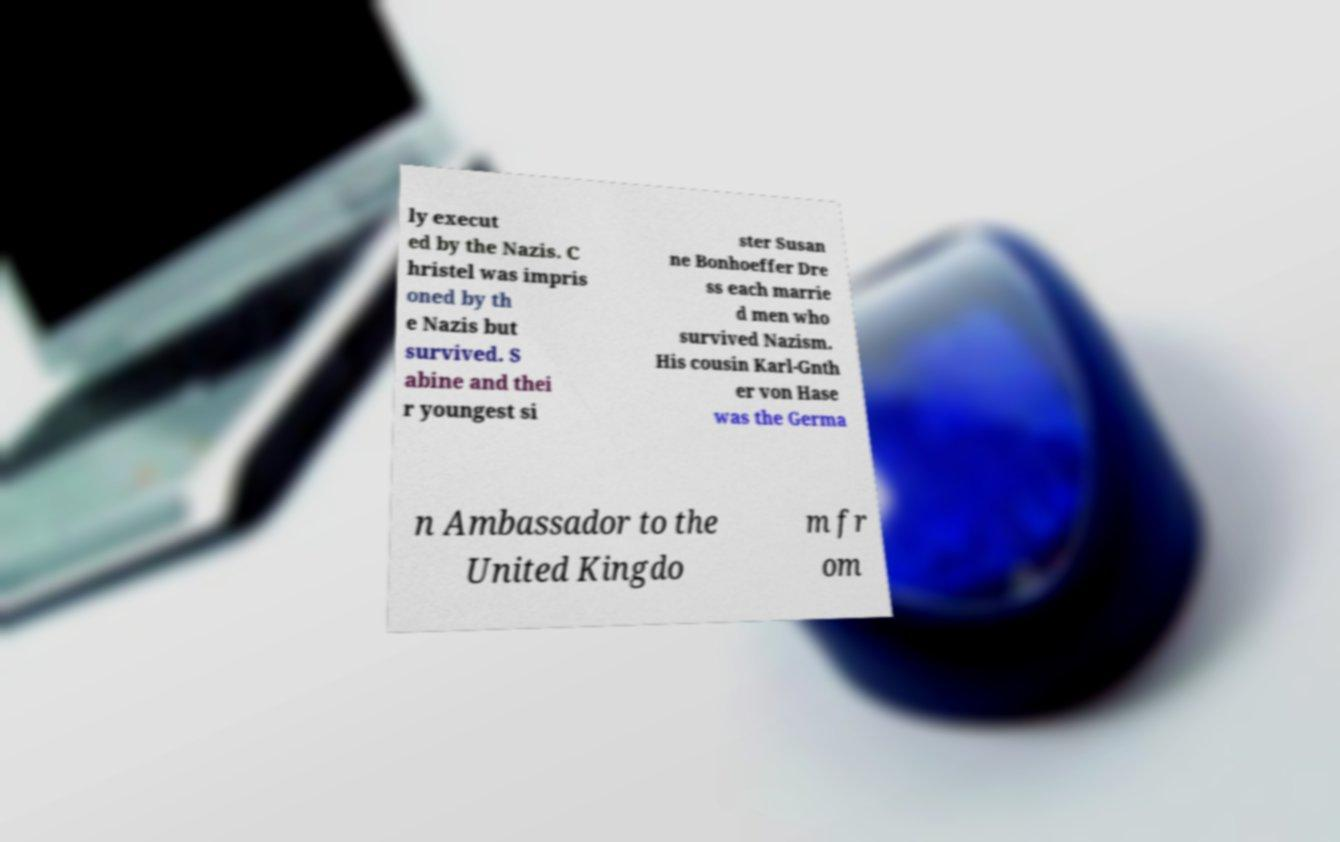Could you extract and type out the text from this image? ly execut ed by the Nazis. C hristel was impris oned by th e Nazis but survived. S abine and thei r youngest si ster Susan ne Bonhoeffer Dre ss each marrie d men who survived Nazism. His cousin Karl-Gnth er von Hase was the Germa n Ambassador to the United Kingdo m fr om 